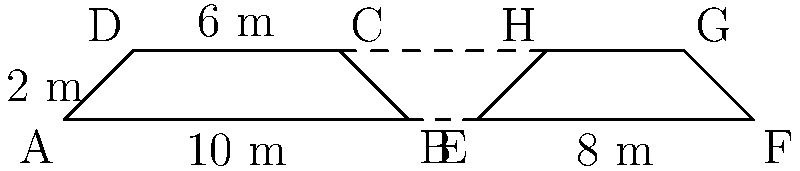In a long jump runway, two congruent trapezoids ABCD and EFGH are marked as shown in the diagram. The lower base of trapezoid ABCD is 10 m, and its height is 2 m. If the distance between points B and E is 2 m, what is the total length of the runway section represented by ABCGHF? Let's approach this step-by-step:

1) First, we need to recognize that trapezoids ABCD and EFGH are congruent. This means they have the same dimensions.

2) We're given that the lower base of ABCD (AB) is 10 m and its height is 2 m.

3) The distance between B and E is 2 m.

4) To find the total length of ABCGHF, we need to add:
   - Length of AB (10 m)
   - Length of BE (2 m)
   - Length of EF (which is equal to AB, 10 m)

5) Mathematically, this can be expressed as:
   $$ \text{Total Length} = AB + BE + EF $$
   $$ \text{Total Length} = 10 \text{ m} + 2 \text{ m} + 10 \text{ m} $$
   $$ \text{Total Length} = 22 \text{ m} $$

Therefore, the total length of the runway section represented by ABCGHF is 22 meters.
Answer: 22 m 